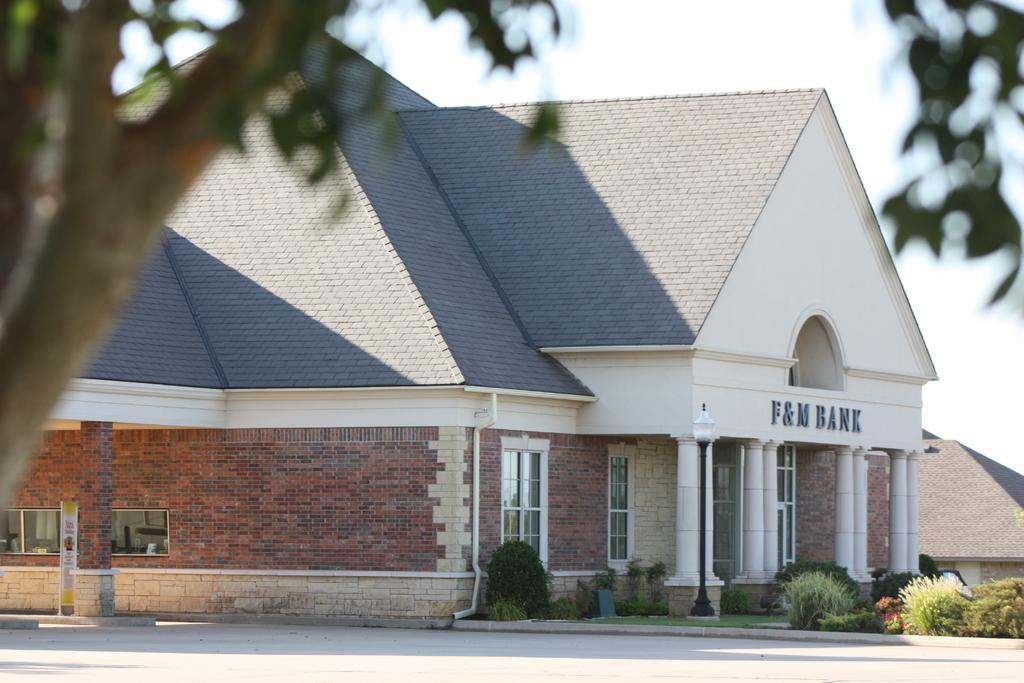What type of building is in the image? There is a beautiful house in the image. What is on top of the house? The house has a roof tile on top. What can be seen in front of the house? There are plants in front of the house. Where is the tree trunk located in the image? There is a tree trunk in the left corner of the image. How many dogs are playing with the boys in the image? There are no dogs or boys present in the image; it features a beautiful house with a roof tile, plants, and a tree trunk. 